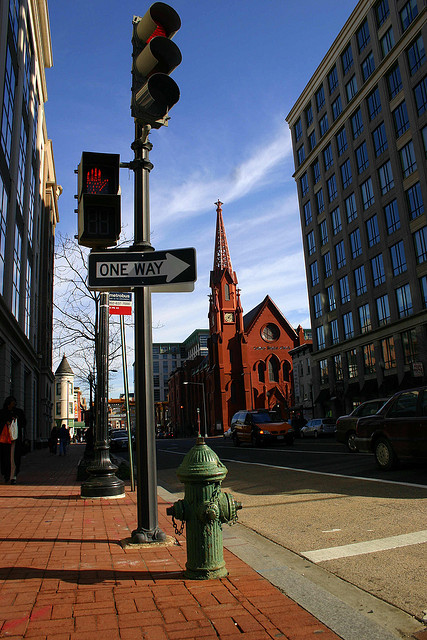How many giraffes are there? 0 